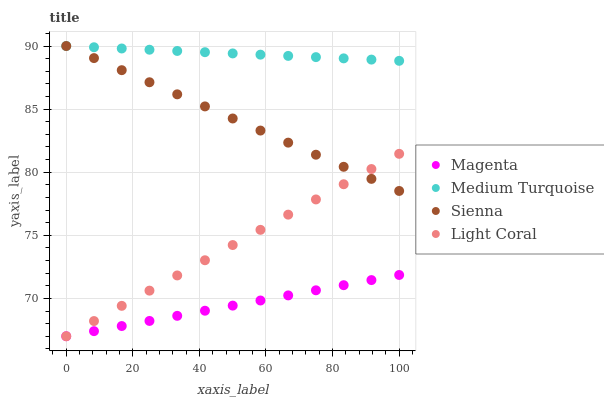Does Magenta have the minimum area under the curve?
Answer yes or no. Yes. Does Medium Turquoise have the maximum area under the curve?
Answer yes or no. Yes. Does Light Coral have the minimum area under the curve?
Answer yes or no. No. Does Light Coral have the maximum area under the curve?
Answer yes or no. No. Is Medium Turquoise the smoothest?
Answer yes or no. Yes. Is Magenta the roughest?
Answer yes or no. Yes. Is Light Coral the smoothest?
Answer yes or no. No. Is Light Coral the roughest?
Answer yes or no. No. Does Light Coral have the lowest value?
Answer yes or no. Yes. Does Medium Turquoise have the lowest value?
Answer yes or no. No. Does Medium Turquoise have the highest value?
Answer yes or no. Yes. Does Light Coral have the highest value?
Answer yes or no. No. Is Light Coral less than Medium Turquoise?
Answer yes or no. Yes. Is Sienna greater than Magenta?
Answer yes or no. Yes. Does Light Coral intersect Magenta?
Answer yes or no. Yes. Is Light Coral less than Magenta?
Answer yes or no. No. Is Light Coral greater than Magenta?
Answer yes or no. No. Does Light Coral intersect Medium Turquoise?
Answer yes or no. No. 